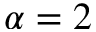Convert formula to latex. <formula><loc_0><loc_0><loc_500><loc_500>\alpha = 2</formula> 